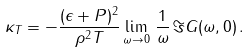Convert formula to latex. <formula><loc_0><loc_0><loc_500><loc_500>\kappa _ { T } = - \frac { ( \epsilon + P ) ^ { 2 } } { \rho ^ { 2 } T } \lim _ { \omega \to 0 } \, \frac { 1 } { \omega } \, \Im G ( \omega , { 0 } ) \, .</formula> 